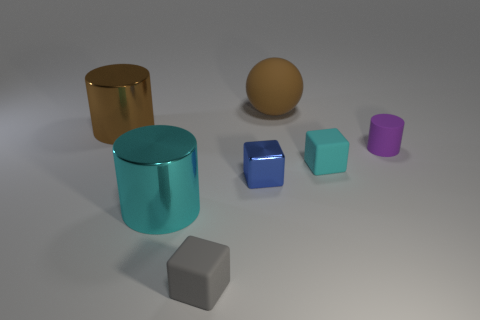Subtract all big cylinders. How many cylinders are left? 1 Subtract all purple cylinders. How many cylinders are left? 2 Subtract all red blocks. Subtract all red spheres. How many blocks are left? 3 Subtract all blue spheres. How many purple cylinders are left? 1 Subtract all large yellow shiny objects. Subtract all big brown balls. How many objects are left? 6 Add 5 big cyan objects. How many big cyan objects are left? 6 Add 2 blue metal spheres. How many blue metal spheres exist? 2 Add 3 small objects. How many objects exist? 10 Subtract 1 brown cylinders. How many objects are left? 6 Subtract all cylinders. How many objects are left? 4 